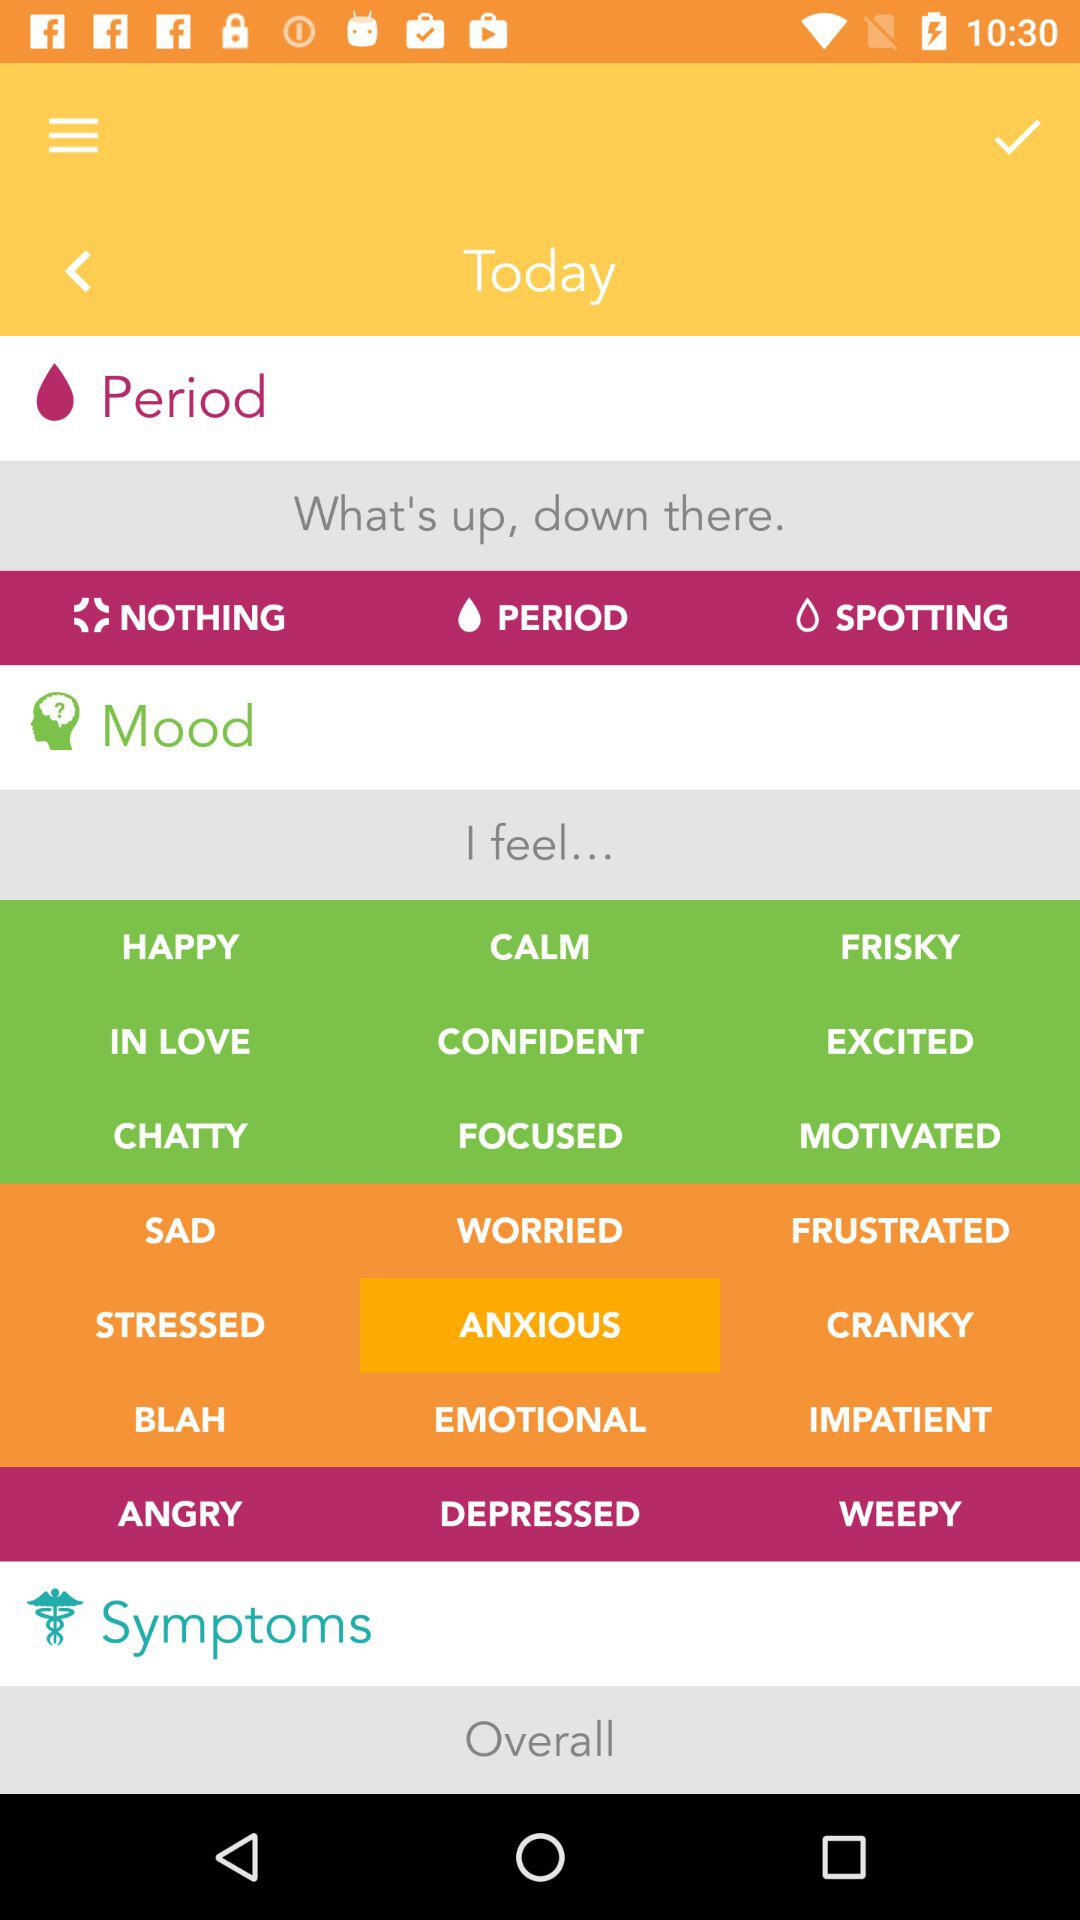What day is selected? The selected day is today. 